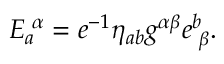<formula> <loc_0><loc_0><loc_500><loc_500>E _ { a } ^ { \, \alpha } = e ^ { - 1 } \eta _ { a b } g ^ { \alpha \beta } e _ { \, \beta } ^ { b } .</formula> 